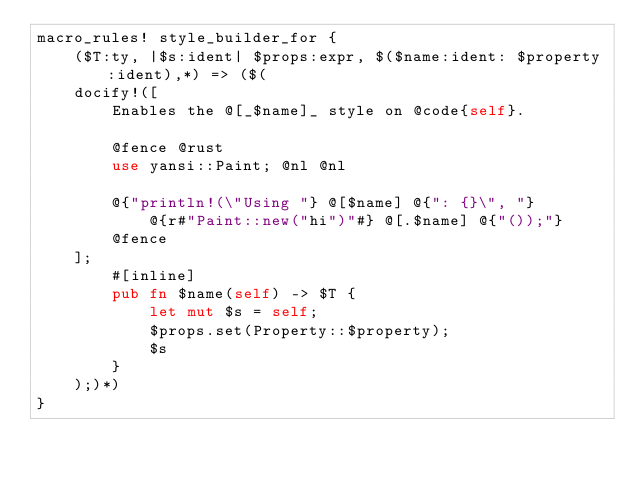Convert code to text. <code><loc_0><loc_0><loc_500><loc_500><_Rust_>macro_rules! style_builder_for {
    ($T:ty, |$s:ident| $props:expr, $($name:ident: $property:ident),*) => ($(
    docify!([
        Enables the @[_$name]_ style on @code{self}.

        @fence @rust
        use yansi::Paint; @nl @nl

        @{"println!(\"Using "} @[$name] @{": {}\", "}
            @{r#"Paint::new("hi")"#} @[.$name] @{"());"}
        @fence
    ];
        #[inline]
        pub fn $name(self) -> $T {
            let mut $s = self;
            $props.set(Property::$property);
            $s
        }
    );)*)
}
</code> 